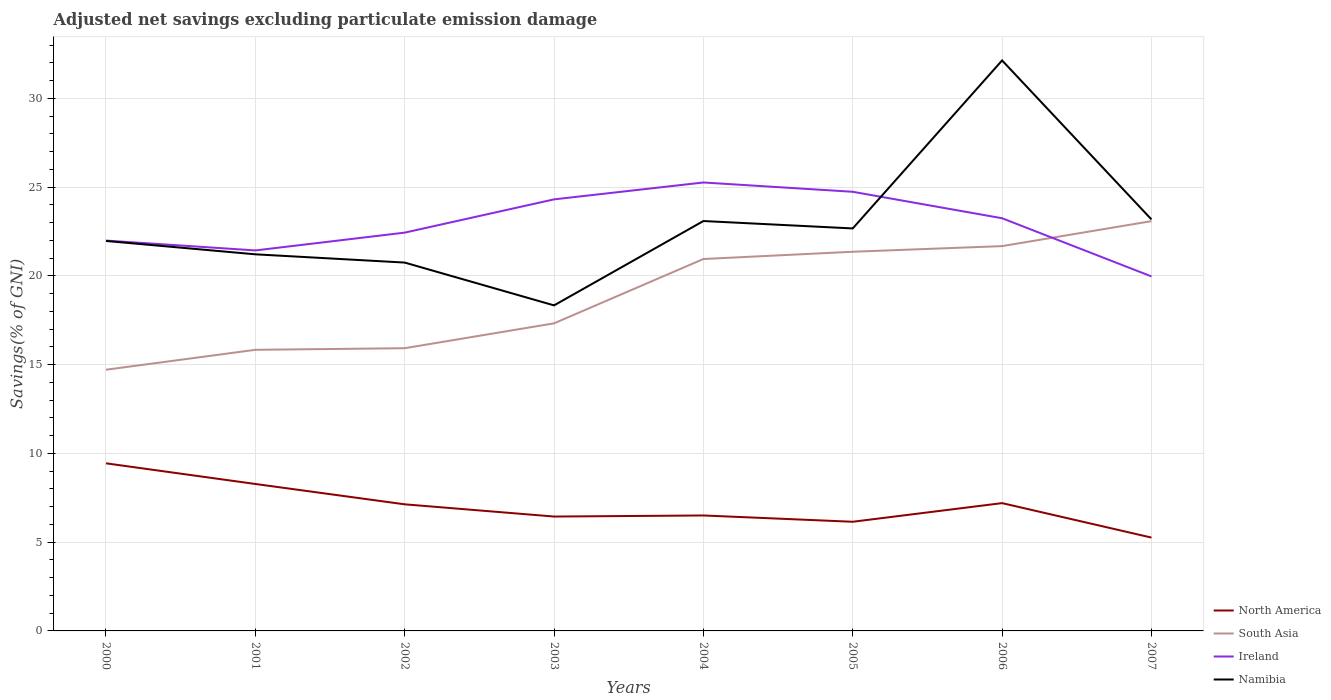Is the number of lines equal to the number of legend labels?
Keep it short and to the point. Yes. Across all years, what is the maximum adjusted net savings in South Asia?
Ensure brevity in your answer.  14.71. In which year was the adjusted net savings in North America maximum?
Ensure brevity in your answer.  2007. What is the total adjusted net savings in South Asia in the graph?
Your answer should be very brief. -5.52. What is the difference between the highest and the second highest adjusted net savings in Ireland?
Offer a terse response. 5.29. What is the difference between the highest and the lowest adjusted net savings in Namibia?
Provide a succinct answer. 3. What is the difference between two consecutive major ticks on the Y-axis?
Your answer should be very brief. 5. Are the values on the major ticks of Y-axis written in scientific E-notation?
Offer a very short reply. No. Does the graph contain any zero values?
Your response must be concise. No. Does the graph contain grids?
Make the answer very short. Yes. How many legend labels are there?
Offer a terse response. 4. What is the title of the graph?
Your answer should be very brief. Adjusted net savings excluding particulate emission damage. What is the label or title of the Y-axis?
Your answer should be very brief. Savings(% of GNI). What is the Savings(% of GNI) of North America in 2000?
Your answer should be compact. 9.44. What is the Savings(% of GNI) of South Asia in 2000?
Provide a succinct answer. 14.71. What is the Savings(% of GNI) of Ireland in 2000?
Provide a short and direct response. 21.99. What is the Savings(% of GNI) of Namibia in 2000?
Offer a very short reply. 21.97. What is the Savings(% of GNI) of North America in 2001?
Offer a terse response. 8.28. What is the Savings(% of GNI) in South Asia in 2001?
Make the answer very short. 15.84. What is the Savings(% of GNI) in Ireland in 2001?
Provide a succinct answer. 21.44. What is the Savings(% of GNI) in Namibia in 2001?
Ensure brevity in your answer.  21.22. What is the Savings(% of GNI) of North America in 2002?
Make the answer very short. 7.13. What is the Savings(% of GNI) in South Asia in 2002?
Offer a very short reply. 15.93. What is the Savings(% of GNI) in Ireland in 2002?
Provide a succinct answer. 22.44. What is the Savings(% of GNI) in Namibia in 2002?
Provide a succinct answer. 20.75. What is the Savings(% of GNI) in North America in 2003?
Provide a succinct answer. 6.44. What is the Savings(% of GNI) in South Asia in 2003?
Offer a terse response. 17.33. What is the Savings(% of GNI) of Ireland in 2003?
Your answer should be very brief. 24.31. What is the Savings(% of GNI) in Namibia in 2003?
Your answer should be very brief. 18.34. What is the Savings(% of GNI) in North America in 2004?
Provide a succinct answer. 6.5. What is the Savings(% of GNI) in South Asia in 2004?
Give a very brief answer. 20.95. What is the Savings(% of GNI) of Ireland in 2004?
Your answer should be compact. 25.26. What is the Savings(% of GNI) of Namibia in 2004?
Offer a very short reply. 23.09. What is the Savings(% of GNI) of North America in 2005?
Offer a terse response. 6.15. What is the Savings(% of GNI) in South Asia in 2005?
Offer a terse response. 21.36. What is the Savings(% of GNI) of Ireland in 2005?
Make the answer very short. 24.74. What is the Savings(% of GNI) in Namibia in 2005?
Keep it short and to the point. 22.68. What is the Savings(% of GNI) in North America in 2006?
Ensure brevity in your answer.  7.2. What is the Savings(% of GNI) in South Asia in 2006?
Make the answer very short. 21.68. What is the Savings(% of GNI) in Ireland in 2006?
Ensure brevity in your answer.  23.25. What is the Savings(% of GNI) of Namibia in 2006?
Your answer should be very brief. 32.14. What is the Savings(% of GNI) of North America in 2007?
Make the answer very short. 5.26. What is the Savings(% of GNI) in South Asia in 2007?
Offer a terse response. 23.09. What is the Savings(% of GNI) in Ireland in 2007?
Offer a terse response. 19.97. What is the Savings(% of GNI) in Namibia in 2007?
Provide a succinct answer. 23.18. Across all years, what is the maximum Savings(% of GNI) in North America?
Your answer should be compact. 9.44. Across all years, what is the maximum Savings(% of GNI) in South Asia?
Keep it short and to the point. 23.09. Across all years, what is the maximum Savings(% of GNI) of Ireland?
Your answer should be compact. 25.26. Across all years, what is the maximum Savings(% of GNI) of Namibia?
Offer a very short reply. 32.14. Across all years, what is the minimum Savings(% of GNI) in North America?
Provide a succinct answer. 5.26. Across all years, what is the minimum Savings(% of GNI) in South Asia?
Ensure brevity in your answer.  14.71. Across all years, what is the minimum Savings(% of GNI) in Ireland?
Keep it short and to the point. 19.97. Across all years, what is the minimum Savings(% of GNI) in Namibia?
Offer a very short reply. 18.34. What is the total Savings(% of GNI) of North America in the graph?
Ensure brevity in your answer.  56.41. What is the total Savings(% of GNI) in South Asia in the graph?
Your answer should be compact. 150.89. What is the total Savings(% of GNI) of Ireland in the graph?
Offer a terse response. 183.4. What is the total Savings(% of GNI) in Namibia in the graph?
Provide a succinct answer. 183.37. What is the difference between the Savings(% of GNI) in North America in 2000 and that in 2001?
Keep it short and to the point. 1.16. What is the difference between the Savings(% of GNI) of South Asia in 2000 and that in 2001?
Give a very brief answer. -1.12. What is the difference between the Savings(% of GNI) in Ireland in 2000 and that in 2001?
Your answer should be very brief. 0.56. What is the difference between the Savings(% of GNI) of Namibia in 2000 and that in 2001?
Provide a short and direct response. 0.75. What is the difference between the Savings(% of GNI) of North America in 2000 and that in 2002?
Offer a very short reply. 2.31. What is the difference between the Savings(% of GNI) of South Asia in 2000 and that in 2002?
Offer a terse response. -1.21. What is the difference between the Savings(% of GNI) of Ireland in 2000 and that in 2002?
Offer a terse response. -0.45. What is the difference between the Savings(% of GNI) in Namibia in 2000 and that in 2002?
Your answer should be compact. 1.22. What is the difference between the Savings(% of GNI) in North America in 2000 and that in 2003?
Give a very brief answer. 3. What is the difference between the Savings(% of GNI) of South Asia in 2000 and that in 2003?
Your response must be concise. -2.61. What is the difference between the Savings(% of GNI) in Ireland in 2000 and that in 2003?
Your answer should be compact. -2.32. What is the difference between the Savings(% of GNI) of Namibia in 2000 and that in 2003?
Your response must be concise. 3.63. What is the difference between the Savings(% of GNI) in North America in 2000 and that in 2004?
Your answer should be compact. 2.94. What is the difference between the Savings(% of GNI) in South Asia in 2000 and that in 2004?
Keep it short and to the point. -6.24. What is the difference between the Savings(% of GNI) of Ireland in 2000 and that in 2004?
Your answer should be very brief. -3.27. What is the difference between the Savings(% of GNI) in Namibia in 2000 and that in 2004?
Provide a succinct answer. -1.12. What is the difference between the Savings(% of GNI) in North America in 2000 and that in 2005?
Your answer should be very brief. 3.29. What is the difference between the Savings(% of GNI) of South Asia in 2000 and that in 2005?
Your response must be concise. -6.65. What is the difference between the Savings(% of GNI) of Ireland in 2000 and that in 2005?
Your response must be concise. -2.75. What is the difference between the Savings(% of GNI) in Namibia in 2000 and that in 2005?
Make the answer very short. -0.71. What is the difference between the Savings(% of GNI) in North America in 2000 and that in 2006?
Provide a succinct answer. 2.24. What is the difference between the Savings(% of GNI) of South Asia in 2000 and that in 2006?
Your response must be concise. -6.96. What is the difference between the Savings(% of GNI) of Ireland in 2000 and that in 2006?
Keep it short and to the point. -1.26. What is the difference between the Savings(% of GNI) of Namibia in 2000 and that in 2006?
Offer a terse response. -10.17. What is the difference between the Savings(% of GNI) in North America in 2000 and that in 2007?
Your response must be concise. 4.18. What is the difference between the Savings(% of GNI) in South Asia in 2000 and that in 2007?
Offer a very short reply. -8.37. What is the difference between the Savings(% of GNI) in Ireland in 2000 and that in 2007?
Give a very brief answer. 2.02. What is the difference between the Savings(% of GNI) of Namibia in 2000 and that in 2007?
Your response must be concise. -1.21. What is the difference between the Savings(% of GNI) in North America in 2001 and that in 2002?
Your response must be concise. 1.15. What is the difference between the Savings(% of GNI) of South Asia in 2001 and that in 2002?
Provide a succinct answer. -0.09. What is the difference between the Savings(% of GNI) in Ireland in 2001 and that in 2002?
Your response must be concise. -1. What is the difference between the Savings(% of GNI) of Namibia in 2001 and that in 2002?
Give a very brief answer. 0.47. What is the difference between the Savings(% of GNI) in North America in 2001 and that in 2003?
Your answer should be very brief. 1.83. What is the difference between the Savings(% of GNI) of South Asia in 2001 and that in 2003?
Provide a short and direct response. -1.49. What is the difference between the Savings(% of GNI) of Ireland in 2001 and that in 2003?
Offer a terse response. -2.88. What is the difference between the Savings(% of GNI) in Namibia in 2001 and that in 2003?
Your answer should be very brief. 2.88. What is the difference between the Savings(% of GNI) of North America in 2001 and that in 2004?
Your response must be concise. 1.77. What is the difference between the Savings(% of GNI) in South Asia in 2001 and that in 2004?
Offer a terse response. -5.12. What is the difference between the Savings(% of GNI) of Ireland in 2001 and that in 2004?
Your answer should be compact. -3.83. What is the difference between the Savings(% of GNI) in Namibia in 2001 and that in 2004?
Your answer should be compact. -1.87. What is the difference between the Savings(% of GNI) in North America in 2001 and that in 2005?
Make the answer very short. 2.13. What is the difference between the Savings(% of GNI) of South Asia in 2001 and that in 2005?
Offer a very short reply. -5.53. What is the difference between the Savings(% of GNI) in Ireland in 2001 and that in 2005?
Your response must be concise. -3.3. What is the difference between the Savings(% of GNI) of Namibia in 2001 and that in 2005?
Keep it short and to the point. -1.46. What is the difference between the Savings(% of GNI) in North America in 2001 and that in 2006?
Offer a very short reply. 1.08. What is the difference between the Savings(% of GNI) of South Asia in 2001 and that in 2006?
Your answer should be compact. -5.84. What is the difference between the Savings(% of GNI) in Ireland in 2001 and that in 2006?
Ensure brevity in your answer.  -1.81. What is the difference between the Savings(% of GNI) in Namibia in 2001 and that in 2006?
Provide a short and direct response. -10.92. What is the difference between the Savings(% of GNI) in North America in 2001 and that in 2007?
Your answer should be very brief. 3.02. What is the difference between the Savings(% of GNI) in South Asia in 2001 and that in 2007?
Provide a short and direct response. -7.25. What is the difference between the Savings(% of GNI) in Ireland in 2001 and that in 2007?
Make the answer very short. 1.46. What is the difference between the Savings(% of GNI) of Namibia in 2001 and that in 2007?
Ensure brevity in your answer.  -1.97. What is the difference between the Savings(% of GNI) of North America in 2002 and that in 2003?
Offer a very short reply. 0.69. What is the difference between the Savings(% of GNI) in South Asia in 2002 and that in 2003?
Offer a very short reply. -1.4. What is the difference between the Savings(% of GNI) of Ireland in 2002 and that in 2003?
Keep it short and to the point. -1.87. What is the difference between the Savings(% of GNI) of Namibia in 2002 and that in 2003?
Your response must be concise. 2.41. What is the difference between the Savings(% of GNI) in North America in 2002 and that in 2004?
Give a very brief answer. 0.63. What is the difference between the Savings(% of GNI) of South Asia in 2002 and that in 2004?
Your answer should be very brief. -5.02. What is the difference between the Savings(% of GNI) in Ireland in 2002 and that in 2004?
Offer a terse response. -2.83. What is the difference between the Savings(% of GNI) of Namibia in 2002 and that in 2004?
Make the answer very short. -2.34. What is the difference between the Savings(% of GNI) of North America in 2002 and that in 2005?
Offer a terse response. 0.98. What is the difference between the Savings(% of GNI) of South Asia in 2002 and that in 2005?
Keep it short and to the point. -5.43. What is the difference between the Savings(% of GNI) of Ireland in 2002 and that in 2005?
Make the answer very short. -2.3. What is the difference between the Savings(% of GNI) of Namibia in 2002 and that in 2005?
Keep it short and to the point. -1.92. What is the difference between the Savings(% of GNI) of North America in 2002 and that in 2006?
Give a very brief answer. -0.07. What is the difference between the Savings(% of GNI) of South Asia in 2002 and that in 2006?
Provide a short and direct response. -5.75. What is the difference between the Savings(% of GNI) of Ireland in 2002 and that in 2006?
Ensure brevity in your answer.  -0.81. What is the difference between the Savings(% of GNI) in Namibia in 2002 and that in 2006?
Offer a terse response. -11.39. What is the difference between the Savings(% of GNI) of North America in 2002 and that in 2007?
Give a very brief answer. 1.87. What is the difference between the Savings(% of GNI) in South Asia in 2002 and that in 2007?
Your response must be concise. -7.16. What is the difference between the Savings(% of GNI) in Ireland in 2002 and that in 2007?
Offer a very short reply. 2.47. What is the difference between the Savings(% of GNI) in Namibia in 2002 and that in 2007?
Your response must be concise. -2.43. What is the difference between the Savings(% of GNI) of North America in 2003 and that in 2004?
Your response must be concise. -0.06. What is the difference between the Savings(% of GNI) of South Asia in 2003 and that in 2004?
Your answer should be very brief. -3.62. What is the difference between the Savings(% of GNI) in Ireland in 2003 and that in 2004?
Offer a terse response. -0.95. What is the difference between the Savings(% of GNI) of Namibia in 2003 and that in 2004?
Keep it short and to the point. -4.75. What is the difference between the Savings(% of GNI) of North America in 2003 and that in 2005?
Your response must be concise. 0.29. What is the difference between the Savings(% of GNI) in South Asia in 2003 and that in 2005?
Provide a succinct answer. -4.03. What is the difference between the Savings(% of GNI) of Ireland in 2003 and that in 2005?
Offer a very short reply. -0.43. What is the difference between the Savings(% of GNI) in Namibia in 2003 and that in 2005?
Your answer should be compact. -4.34. What is the difference between the Savings(% of GNI) in North America in 2003 and that in 2006?
Provide a short and direct response. -0.76. What is the difference between the Savings(% of GNI) in South Asia in 2003 and that in 2006?
Provide a succinct answer. -4.35. What is the difference between the Savings(% of GNI) in Ireland in 2003 and that in 2006?
Your response must be concise. 1.06. What is the difference between the Savings(% of GNI) of Namibia in 2003 and that in 2006?
Your answer should be compact. -13.8. What is the difference between the Savings(% of GNI) in North America in 2003 and that in 2007?
Your answer should be very brief. 1.19. What is the difference between the Savings(% of GNI) of South Asia in 2003 and that in 2007?
Make the answer very short. -5.76. What is the difference between the Savings(% of GNI) in Ireland in 2003 and that in 2007?
Keep it short and to the point. 4.34. What is the difference between the Savings(% of GNI) of Namibia in 2003 and that in 2007?
Ensure brevity in your answer.  -4.84. What is the difference between the Savings(% of GNI) of North America in 2004 and that in 2005?
Your answer should be very brief. 0.35. What is the difference between the Savings(% of GNI) of South Asia in 2004 and that in 2005?
Offer a terse response. -0.41. What is the difference between the Savings(% of GNI) in Ireland in 2004 and that in 2005?
Keep it short and to the point. 0.52. What is the difference between the Savings(% of GNI) of Namibia in 2004 and that in 2005?
Make the answer very short. 0.42. What is the difference between the Savings(% of GNI) of North America in 2004 and that in 2006?
Provide a succinct answer. -0.7. What is the difference between the Savings(% of GNI) in South Asia in 2004 and that in 2006?
Offer a terse response. -0.73. What is the difference between the Savings(% of GNI) of Ireland in 2004 and that in 2006?
Give a very brief answer. 2.01. What is the difference between the Savings(% of GNI) of Namibia in 2004 and that in 2006?
Ensure brevity in your answer.  -9.05. What is the difference between the Savings(% of GNI) of North America in 2004 and that in 2007?
Ensure brevity in your answer.  1.25. What is the difference between the Savings(% of GNI) in South Asia in 2004 and that in 2007?
Provide a short and direct response. -2.13. What is the difference between the Savings(% of GNI) in Ireland in 2004 and that in 2007?
Offer a very short reply. 5.29. What is the difference between the Savings(% of GNI) in Namibia in 2004 and that in 2007?
Your answer should be compact. -0.09. What is the difference between the Savings(% of GNI) of North America in 2005 and that in 2006?
Offer a very short reply. -1.05. What is the difference between the Savings(% of GNI) in South Asia in 2005 and that in 2006?
Keep it short and to the point. -0.32. What is the difference between the Savings(% of GNI) of Ireland in 2005 and that in 2006?
Provide a succinct answer. 1.49. What is the difference between the Savings(% of GNI) of Namibia in 2005 and that in 2006?
Keep it short and to the point. -9.46. What is the difference between the Savings(% of GNI) in North America in 2005 and that in 2007?
Offer a very short reply. 0.89. What is the difference between the Savings(% of GNI) of South Asia in 2005 and that in 2007?
Offer a terse response. -1.72. What is the difference between the Savings(% of GNI) in Ireland in 2005 and that in 2007?
Your response must be concise. 4.77. What is the difference between the Savings(% of GNI) of Namibia in 2005 and that in 2007?
Your answer should be very brief. -0.51. What is the difference between the Savings(% of GNI) in North America in 2006 and that in 2007?
Your response must be concise. 1.94. What is the difference between the Savings(% of GNI) of South Asia in 2006 and that in 2007?
Offer a very short reply. -1.41. What is the difference between the Savings(% of GNI) in Ireland in 2006 and that in 2007?
Provide a succinct answer. 3.28. What is the difference between the Savings(% of GNI) of Namibia in 2006 and that in 2007?
Provide a short and direct response. 8.96. What is the difference between the Savings(% of GNI) of North America in 2000 and the Savings(% of GNI) of South Asia in 2001?
Give a very brief answer. -6.39. What is the difference between the Savings(% of GNI) in North America in 2000 and the Savings(% of GNI) in Ireland in 2001?
Keep it short and to the point. -11.99. What is the difference between the Savings(% of GNI) in North America in 2000 and the Savings(% of GNI) in Namibia in 2001?
Offer a terse response. -11.77. What is the difference between the Savings(% of GNI) in South Asia in 2000 and the Savings(% of GNI) in Ireland in 2001?
Ensure brevity in your answer.  -6.72. What is the difference between the Savings(% of GNI) of South Asia in 2000 and the Savings(% of GNI) of Namibia in 2001?
Ensure brevity in your answer.  -6.5. What is the difference between the Savings(% of GNI) in Ireland in 2000 and the Savings(% of GNI) in Namibia in 2001?
Give a very brief answer. 0.77. What is the difference between the Savings(% of GNI) in North America in 2000 and the Savings(% of GNI) in South Asia in 2002?
Offer a very short reply. -6.49. What is the difference between the Savings(% of GNI) in North America in 2000 and the Savings(% of GNI) in Ireland in 2002?
Your answer should be compact. -13. What is the difference between the Savings(% of GNI) in North America in 2000 and the Savings(% of GNI) in Namibia in 2002?
Your answer should be compact. -11.31. What is the difference between the Savings(% of GNI) of South Asia in 2000 and the Savings(% of GNI) of Ireland in 2002?
Keep it short and to the point. -7.72. What is the difference between the Savings(% of GNI) in South Asia in 2000 and the Savings(% of GNI) in Namibia in 2002?
Your answer should be very brief. -6.04. What is the difference between the Savings(% of GNI) of Ireland in 2000 and the Savings(% of GNI) of Namibia in 2002?
Provide a succinct answer. 1.24. What is the difference between the Savings(% of GNI) in North America in 2000 and the Savings(% of GNI) in South Asia in 2003?
Offer a terse response. -7.89. What is the difference between the Savings(% of GNI) of North America in 2000 and the Savings(% of GNI) of Ireland in 2003?
Provide a succinct answer. -14.87. What is the difference between the Savings(% of GNI) in North America in 2000 and the Savings(% of GNI) in Namibia in 2003?
Provide a succinct answer. -8.9. What is the difference between the Savings(% of GNI) in South Asia in 2000 and the Savings(% of GNI) in Ireland in 2003?
Your answer should be compact. -9.6. What is the difference between the Savings(% of GNI) of South Asia in 2000 and the Savings(% of GNI) of Namibia in 2003?
Provide a succinct answer. -3.62. What is the difference between the Savings(% of GNI) of Ireland in 2000 and the Savings(% of GNI) of Namibia in 2003?
Offer a terse response. 3.65. What is the difference between the Savings(% of GNI) of North America in 2000 and the Savings(% of GNI) of South Asia in 2004?
Your response must be concise. -11.51. What is the difference between the Savings(% of GNI) of North America in 2000 and the Savings(% of GNI) of Ireland in 2004?
Offer a very short reply. -15.82. What is the difference between the Savings(% of GNI) in North America in 2000 and the Savings(% of GNI) in Namibia in 2004?
Ensure brevity in your answer.  -13.65. What is the difference between the Savings(% of GNI) in South Asia in 2000 and the Savings(% of GNI) in Ireland in 2004?
Offer a terse response. -10.55. What is the difference between the Savings(% of GNI) of South Asia in 2000 and the Savings(% of GNI) of Namibia in 2004?
Provide a short and direct response. -8.38. What is the difference between the Savings(% of GNI) in Ireland in 2000 and the Savings(% of GNI) in Namibia in 2004?
Give a very brief answer. -1.1. What is the difference between the Savings(% of GNI) in North America in 2000 and the Savings(% of GNI) in South Asia in 2005?
Offer a terse response. -11.92. What is the difference between the Savings(% of GNI) of North America in 2000 and the Savings(% of GNI) of Ireland in 2005?
Your answer should be compact. -15.3. What is the difference between the Savings(% of GNI) in North America in 2000 and the Savings(% of GNI) in Namibia in 2005?
Keep it short and to the point. -13.23. What is the difference between the Savings(% of GNI) in South Asia in 2000 and the Savings(% of GNI) in Ireland in 2005?
Keep it short and to the point. -10.02. What is the difference between the Savings(% of GNI) in South Asia in 2000 and the Savings(% of GNI) in Namibia in 2005?
Provide a short and direct response. -7.96. What is the difference between the Savings(% of GNI) in Ireland in 2000 and the Savings(% of GNI) in Namibia in 2005?
Offer a terse response. -0.68. What is the difference between the Savings(% of GNI) of North America in 2000 and the Savings(% of GNI) of South Asia in 2006?
Ensure brevity in your answer.  -12.24. What is the difference between the Savings(% of GNI) in North America in 2000 and the Savings(% of GNI) in Ireland in 2006?
Your answer should be compact. -13.81. What is the difference between the Savings(% of GNI) in North America in 2000 and the Savings(% of GNI) in Namibia in 2006?
Offer a very short reply. -22.7. What is the difference between the Savings(% of GNI) of South Asia in 2000 and the Savings(% of GNI) of Ireland in 2006?
Offer a terse response. -8.53. What is the difference between the Savings(% of GNI) in South Asia in 2000 and the Savings(% of GNI) in Namibia in 2006?
Your answer should be compact. -17.43. What is the difference between the Savings(% of GNI) in Ireland in 2000 and the Savings(% of GNI) in Namibia in 2006?
Make the answer very short. -10.15. What is the difference between the Savings(% of GNI) of North America in 2000 and the Savings(% of GNI) of South Asia in 2007?
Your answer should be compact. -13.64. What is the difference between the Savings(% of GNI) of North America in 2000 and the Savings(% of GNI) of Ireland in 2007?
Your response must be concise. -10.53. What is the difference between the Savings(% of GNI) of North America in 2000 and the Savings(% of GNI) of Namibia in 2007?
Your response must be concise. -13.74. What is the difference between the Savings(% of GNI) of South Asia in 2000 and the Savings(% of GNI) of Ireland in 2007?
Your answer should be compact. -5.26. What is the difference between the Savings(% of GNI) of South Asia in 2000 and the Savings(% of GNI) of Namibia in 2007?
Your response must be concise. -8.47. What is the difference between the Savings(% of GNI) of Ireland in 2000 and the Savings(% of GNI) of Namibia in 2007?
Give a very brief answer. -1.19. What is the difference between the Savings(% of GNI) of North America in 2001 and the Savings(% of GNI) of South Asia in 2002?
Your response must be concise. -7.65. What is the difference between the Savings(% of GNI) in North America in 2001 and the Savings(% of GNI) in Ireland in 2002?
Provide a short and direct response. -14.16. What is the difference between the Savings(% of GNI) in North America in 2001 and the Savings(% of GNI) in Namibia in 2002?
Your answer should be compact. -12.47. What is the difference between the Savings(% of GNI) in South Asia in 2001 and the Savings(% of GNI) in Ireland in 2002?
Your response must be concise. -6.6. What is the difference between the Savings(% of GNI) of South Asia in 2001 and the Savings(% of GNI) of Namibia in 2002?
Offer a terse response. -4.92. What is the difference between the Savings(% of GNI) in Ireland in 2001 and the Savings(% of GNI) in Namibia in 2002?
Provide a short and direct response. 0.68. What is the difference between the Savings(% of GNI) of North America in 2001 and the Savings(% of GNI) of South Asia in 2003?
Keep it short and to the point. -9.05. What is the difference between the Savings(% of GNI) of North America in 2001 and the Savings(% of GNI) of Ireland in 2003?
Your answer should be compact. -16.03. What is the difference between the Savings(% of GNI) of North America in 2001 and the Savings(% of GNI) of Namibia in 2003?
Provide a succinct answer. -10.06. What is the difference between the Savings(% of GNI) of South Asia in 2001 and the Savings(% of GNI) of Ireland in 2003?
Ensure brevity in your answer.  -8.48. What is the difference between the Savings(% of GNI) in South Asia in 2001 and the Savings(% of GNI) in Namibia in 2003?
Offer a very short reply. -2.5. What is the difference between the Savings(% of GNI) in Ireland in 2001 and the Savings(% of GNI) in Namibia in 2003?
Ensure brevity in your answer.  3.1. What is the difference between the Savings(% of GNI) of North America in 2001 and the Savings(% of GNI) of South Asia in 2004?
Make the answer very short. -12.67. What is the difference between the Savings(% of GNI) in North America in 2001 and the Savings(% of GNI) in Ireland in 2004?
Make the answer very short. -16.98. What is the difference between the Savings(% of GNI) of North America in 2001 and the Savings(% of GNI) of Namibia in 2004?
Provide a short and direct response. -14.81. What is the difference between the Savings(% of GNI) in South Asia in 2001 and the Savings(% of GNI) in Ireland in 2004?
Ensure brevity in your answer.  -9.43. What is the difference between the Savings(% of GNI) of South Asia in 2001 and the Savings(% of GNI) of Namibia in 2004?
Offer a very short reply. -7.26. What is the difference between the Savings(% of GNI) of Ireland in 2001 and the Savings(% of GNI) of Namibia in 2004?
Your answer should be compact. -1.66. What is the difference between the Savings(% of GNI) of North America in 2001 and the Savings(% of GNI) of South Asia in 2005?
Your answer should be very brief. -13.08. What is the difference between the Savings(% of GNI) in North America in 2001 and the Savings(% of GNI) in Ireland in 2005?
Provide a succinct answer. -16.46. What is the difference between the Savings(% of GNI) in North America in 2001 and the Savings(% of GNI) in Namibia in 2005?
Offer a terse response. -14.4. What is the difference between the Savings(% of GNI) of South Asia in 2001 and the Savings(% of GNI) of Ireland in 2005?
Make the answer very short. -8.9. What is the difference between the Savings(% of GNI) in South Asia in 2001 and the Savings(% of GNI) in Namibia in 2005?
Your answer should be very brief. -6.84. What is the difference between the Savings(% of GNI) of Ireland in 2001 and the Savings(% of GNI) of Namibia in 2005?
Make the answer very short. -1.24. What is the difference between the Savings(% of GNI) of North America in 2001 and the Savings(% of GNI) of South Asia in 2006?
Your answer should be very brief. -13.4. What is the difference between the Savings(% of GNI) in North America in 2001 and the Savings(% of GNI) in Ireland in 2006?
Your response must be concise. -14.97. What is the difference between the Savings(% of GNI) in North America in 2001 and the Savings(% of GNI) in Namibia in 2006?
Your response must be concise. -23.86. What is the difference between the Savings(% of GNI) of South Asia in 2001 and the Savings(% of GNI) of Ireland in 2006?
Give a very brief answer. -7.41. What is the difference between the Savings(% of GNI) of South Asia in 2001 and the Savings(% of GNI) of Namibia in 2006?
Offer a terse response. -16.3. What is the difference between the Savings(% of GNI) of Ireland in 2001 and the Savings(% of GNI) of Namibia in 2006?
Ensure brevity in your answer.  -10.7. What is the difference between the Savings(% of GNI) of North America in 2001 and the Savings(% of GNI) of South Asia in 2007?
Keep it short and to the point. -14.81. What is the difference between the Savings(% of GNI) in North America in 2001 and the Savings(% of GNI) in Ireland in 2007?
Your answer should be compact. -11.69. What is the difference between the Savings(% of GNI) in North America in 2001 and the Savings(% of GNI) in Namibia in 2007?
Keep it short and to the point. -14.9. What is the difference between the Savings(% of GNI) of South Asia in 2001 and the Savings(% of GNI) of Ireland in 2007?
Your answer should be compact. -4.14. What is the difference between the Savings(% of GNI) in South Asia in 2001 and the Savings(% of GNI) in Namibia in 2007?
Your response must be concise. -7.35. What is the difference between the Savings(% of GNI) of Ireland in 2001 and the Savings(% of GNI) of Namibia in 2007?
Make the answer very short. -1.75. What is the difference between the Savings(% of GNI) in North America in 2002 and the Savings(% of GNI) in South Asia in 2003?
Your response must be concise. -10.2. What is the difference between the Savings(% of GNI) of North America in 2002 and the Savings(% of GNI) of Ireland in 2003?
Make the answer very short. -17.18. What is the difference between the Savings(% of GNI) of North America in 2002 and the Savings(% of GNI) of Namibia in 2003?
Offer a terse response. -11.21. What is the difference between the Savings(% of GNI) of South Asia in 2002 and the Savings(% of GNI) of Ireland in 2003?
Give a very brief answer. -8.38. What is the difference between the Savings(% of GNI) in South Asia in 2002 and the Savings(% of GNI) in Namibia in 2003?
Provide a short and direct response. -2.41. What is the difference between the Savings(% of GNI) of Ireland in 2002 and the Savings(% of GNI) of Namibia in 2003?
Provide a short and direct response. 4.1. What is the difference between the Savings(% of GNI) of North America in 2002 and the Savings(% of GNI) of South Asia in 2004?
Offer a very short reply. -13.82. What is the difference between the Savings(% of GNI) of North America in 2002 and the Savings(% of GNI) of Ireland in 2004?
Provide a short and direct response. -18.13. What is the difference between the Savings(% of GNI) in North America in 2002 and the Savings(% of GNI) in Namibia in 2004?
Your answer should be compact. -15.96. What is the difference between the Savings(% of GNI) of South Asia in 2002 and the Savings(% of GNI) of Ireland in 2004?
Keep it short and to the point. -9.34. What is the difference between the Savings(% of GNI) of South Asia in 2002 and the Savings(% of GNI) of Namibia in 2004?
Give a very brief answer. -7.16. What is the difference between the Savings(% of GNI) in Ireland in 2002 and the Savings(% of GNI) in Namibia in 2004?
Your answer should be compact. -0.65. What is the difference between the Savings(% of GNI) of North America in 2002 and the Savings(% of GNI) of South Asia in 2005?
Give a very brief answer. -14.23. What is the difference between the Savings(% of GNI) of North America in 2002 and the Savings(% of GNI) of Ireland in 2005?
Provide a short and direct response. -17.61. What is the difference between the Savings(% of GNI) in North America in 2002 and the Savings(% of GNI) in Namibia in 2005?
Provide a succinct answer. -15.54. What is the difference between the Savings(% of GNI) of South Asia in 2002 and the Savings(% of GNI) of Ireland in 2005?
Your answer should be very brief. -8.81. What is the difference between the Savings(% of GNI) in South Asia in 2002 and the Savings(% of GNI) in Namibia in 2005?
Your answer should be compact. -6.75. What is the difference between the Savings(% of GNI) in Ireland in 2002 and the Savings(% of GNI) in Namibia in 2005?
Provide a short and direct response. -0.24. What is the difference between the Savings(% of GNI) in North America in 2002 and the Savings(% of GNI) in South Asia in 2006?
Provide a succinct answer. -14.55. What is the difference between the Savings(% of GNI) in North America in 2002 and the Savings(% of GNI) in Ireland in 2006?
Offer a very short reply. -16.12. What is the difference between the Savings(% of GNI) in North America in 2002 and the Savings(% of GNI) in Namibia in 2006?
Provide a succinct answer. -25.01. What is the difference between the Savings(% of GNI) in South Asia in 2002 and the Savings(% of GNI) in Ireland in 2006?
Offer a terse response. -7.32. What is the difference between the Savings(% of GNI) of South Asia in 2002 and the Savings(% of GNI) of Namibia in 2006?
Make the answer very short. -16.21. What is the difference between the Savings(% of GNI) of Ireland in 2002 and the Savings(% of GNI) of Namibia in 2006?
Provide a short and direct response. -9.7. What is the difference between the Savings(% of GNI) in North America in 2002 and the Savings(% of GNI) in South Asia in 2007?
Give a very brief answer. -15.95. What is the difference between the Savings(% of GNI) in North America in 2002 and the Savings(% of GNI) in Ireland in 2007?
Offer a very short reply. -12.84. What is the difference between the Savings(% of GNI) in North America in 2002 and the Savings(% of GNI) in Namibia in 2007?
Ensure brevity in your answer.  -16.05. What is the difference between the Savings(% of GNI) in South Asia in 2002 and the Savings(% of GNI) in Ireland in 2007?
Your answer should be compact. -4.04. What is the difference between the Savings(% of GNI) of South Asia in 2002 and the Savings(% of GNI) of Namibia in 2007?
Keep it short and to the point. -7.26. What is the difference between the Savings(% of GNI) in Ireland in 2002 and the Savings(% of GNI) in Namibia in 2007?
Provide a short and direct response. -0.75. What is the difference between the Savings(% of GNI) of North America in 2003 and the Savings(% of GNI) of South Asia in 2004?
Give a very brief answer. -14.51. What is the difference between the Savings(% of GNI) of North America in 2003 and the Savings(% of GNI) of Ireland in 2004?
Offer a terse response. -18.82. What is the difference between the Savings(% of GNI) of North America in 2003 and the Savings(% of GNI) of Namibia in 2004?
Offer a very short reply. -16.65. What is the difference between the Savings(% of GNI) in South Asia in 2003 and the Savings(% of GNI) in Ireland in 2004?
Your answer should be very brief. -7.94. What is the difference between the Savings(% of GNI) in South Asia in 2003 and the Savings(% of GNI) in Namibia in 2004?
Your response must be concise. -5.76. What is the difference between the Savings(% of GNI) in Ireland in 2003 and the Savings(% of GNI) in Namibia in 2004?
Keep it short and to the point. 1.22. What is the difference between the Savings(% of GNI) of North America in 2003 and the Savings(% of GNI) of South Asia in 2005?
Ensure brevity in your answer.  -14.92. What is the difference between the Savings(% of GNI) in North America in 2003 and the Savings(% of GNI) in Ireland in 2005?
Offer a very short reply. -18.3. What is the difference between the Savings(% of GNI) of North America in 2003 and the Savings(% of GNI) of Namibia in 2005?
Your answer should be compact. -16.23. What is the difference between the Savings(% of GNI) of South Asia in 2003 and the Savings(% of GNI) of Ireland in 2005?
Offer a terse response. -7.41. What is the difference between the Savings(% of GNI) of South Asia in 2003 and the Savings(% of GNI) of Namibia in 2005?
Make the answer very short. -5.35. What is the difference between the Savings(% of GNI) in Ireland in 2003 and the Savings(% of GNI) in Namibia in 2005?
Make the answer very short. 1.64. What is the difference between the Savings(% of GNI) in North America in 2003 and the Savings(% of GNI) in South Asia in 2006?
Give a very brief answer. -15.24. What is the difference between the Savings(% of GNI) in North America in 2003 and the Savings(% of GNI) in Ireland in 2006?
Your answer should be very brief. -16.81. What is the difference between the Savings(% of GNI) in North America in 2003 and the Savings(% of GNI) in Namibia in 2006?
Provide a succinct answer. -25.7. What is the difference between the Savings(% of GNI) in South Asia in 2003 and the Savings(% of GNI) in Ireland in 2006?
Make the answer very short. -5.92. What is the difference between the Savings(% of GNI) in South Asia in 2003 and the Savings(% of GNI) in Namibia in 2006?
Keep it short and to the point. -14.81. What is the difference between the Savings(% of GNI) in Ireland in 2003 and the Savings(% of GNI) in Namibia in 2006?
Make the answer very short. -7.83. What is the difference between the Savings(% of GNI) of North America in 2003 and the Savings(% of GNI) of South Asia in 2007?
Provide a succinct answer. -16.64. What is the difference between the Savings(% of GNI) in North America in 2003 and the Savings(% of GNI) in Ireland in 2007?
Give a very brief answer. -13.53. What is the difference between the Savings(% of GNI) of North America in 2003 and the Savings(% of GNI) of Namibia in 2007?
Keep it short and to the point. -16.74. What is the difference between the Savings(% of GNI) of South Asia in 2003 and the Savings(% of GNI) of Ireland in 2007?
Your response must be concise. -2.64. What is the difference between the Savings(% of GNI) in South Asia in 2003 and the Savings(% of GNI) in Namibia in 2007?
Ensure brevity in your answer.  -5.86. What is the difference between the Savings(% of GNI) of Ireland in 2003 and the Savings(% of GNI) of Namibia in 2007?
Ensure brevity in your answer.  1.13. What is the difference between the Savings(% of GNI) in North America in 2004 and the Savings(% of GNI) in South Asia in 2005?
Offer a very short reply. -14.86. What is the difference between the Savings(% of GNI) of North America in 2004 and the Savings(% of GNI) of Ireland in 2005?
Ensure brevity in your answer.  -18.24. What is the difference between the Savings(% of GNI) of North America in 2004 and the Savings(% of GNI) of Namibia in 2005?
Make the answer very short. -16.17. What is the difference between the Savings(% of GNI) of South Asia in 2004 and the Savings(% of GNI) of Ireland in 2005?
Provide a succinct answer. -3.79. What is the difference between the Savings(% of GNI) in South Asia in 2004 and the Savings(% of GNI) in Namibia in 2005?
Keep it short and to the point. -1.72. What is the difference between the Savings(% of GNI) of Ireland in 2004 and the Savings(% of GNI) of Namibia in 2005?
Keep it short and to the point. 2.59. What is the difference between the Savings(% of GNI) in North America in 2004 and the Savings(% of GNI) in South Asia in 2006?
Give a very brief answer. -15.18. What is the difference between the Savings(% of GNI) in North America in 2004 and the Savings(% of GNI) in Ireland in 2006?
Keep it short and to the point. -16.75. What is the difference between the Savings(% of GNI) in North America in 2004 and the Savings(% of GNI) in Namibia in 2006?
Offer a terse response. -25.64. What is the difference between the Savings(% of GNI) of South Asia in 2004 and the Savings(% of GNI) of Ireland in 2006?
Make the answer very short. -2.3. What is the difference between the Savings(% of GNI) of South Asia in 2004 and the Savings(% of GNI) of Namibia in 2006?
Offer a terse response. -11.19. What is the difference between the Savings(% of GNI) in Ireland in 2004 and the Savings(% of GNI) in Namibia in 2006?
Provide a succinct answer. -6.88. What is the difference between the Savings(% of GNI) of North America in 2004 and the Savings(% of GNI) of South Asia in 2007?
Your answer should be compact. -16.58. What is the difference between the Savings(% of GNI) in North America in 2004 and the Savings(% of GNI) in Ireland in 2007?
Keep it short and to the point. -13.47. What is the difference between the Savings(% of GNI) in North America in 2004 and the Savings(% of GNI) in Namibia in 2007?
Offer a very short reply. -16.68. What is the difference between the Savings(% of GNI) of South Asia in 2004 and the Savings(% of GNI) of Ireland in 2007?
Offer a terse response. 0.98. What is the difference between the Savings(% of GNI) in South Asia in 2004 and the Savings(% of GNI) in Namibia in 2007?
Give a very brief answer. -2.23. What is the difference between the Savings(% of GNI) of Ireland in 2004 and the Savings(% of GNI) of Namibia in 2007?
Make the answer very short. 2.08. What is the difference between the Savings(% of GNI) of North America in 2005 and the Savings(% of GNI) of South Asia in 2006?
Offer a terse response. -15.53. What is the difference between the Savings(% of GNI) in North America in 2005 and the Savings(% of GNI) in Ireland in 2006?
Your answer should be very brief. -17.1. What is the difference between the Savings(% of GNI) in North America in 2005 and the Savings(% of GNI) in Namibia in 2006?
Your answer should be compact. -25.99. What is the difference between the Savings(% of GNI) of South Asia in 2005 and the Savings(% of GNI) of Ireland in 2006?
Make the answer very short. -1.89. What is the difference between the Savings(% of GNI) in South Asia in 2005 and the Savings(% of GNI) in Namibia in 2006?
Offer a terse response. -10.78. What is the difference between the Savings(% of GNI) of Ireland in 2005 and the Savings(% of GNI) of Namibia in 2006?
Your answer should be compact. -7.4. What is the difference between the Savings(% of GNI) in North America in 2005 and the Savings(% of GNI) in South Asia in 2007?
Offer a very short reply. -16.94. What is the difference between the Savings(% of GNI) of North America in 2005 and the Savings(% of GNI) of Ireland in 2007?
Ensure brevity in your answer.  -13.82. What is the difference between the Savings(% of GNI) of North America in 2005 and the Savings(% of GNI) of Namibia in 2007?
Offer a very short reply. -17.03. What is the difference between the Savings(% of GNI) of South Asia in 2005 and the Savings(% of GNI) of Ireland in 2007?
Offer a very short reply. 1.39. What is the difference between the Savings(% of GNI) of South Asia in 2005 and the Savings(% of GNI) of Namibia in 2007?
Keep it short and to the point. -1.82. What is the difference between the Savings(% of GNI) in Ireland in 2005 and the Savings(% of GNI) in Namibia in 2007?
Give a very brief answer. 1.56. What is the difference between the Savings(% of GNI) of North America in 2006 and the Savings(% of GNI) of South Asia in 2007?
Provide a succinct answer. -15.89. What is the difference between the Savings(% of GNI) of North America in 2006 and the Savings(% of GNI) of Ireland in 2007?
Ensure brevity in your answer.  -12.77. What is the difference between the Savings(% of GNI) in North America in 2006 and the Savings(% of GNI) in Namibia in 2007?
Provide a succinct answer. -15.98. What is the difference between the Savings(% of GNI) of South Asia in 2006 and the Savings(% of GNI) of Ireland in 2007?
Ensure brevity in your answer.  1.71. What is the difference between the Savings(% of GNI) in South Asia in 2006 and the Savings(% of GNI) in Namibia in 2007?
Your answer should be compact. -1.5. What is the difference between the Savings(% of GNI) of Ireland in 2006 and the Savings(% of GNI) of Namibia in 2007?
Provide a short and direct response. 0.07. What is the average Savings(% of GNI) of North America per year?
Ensure brevity in your answer.  7.05. What is the average Savings(% of GNI) of South Asia per year?
Ensure brevity in your answer.  18.86. What is the average Savings(% of GNI) of Ireland per year?
Provide a short and direct response. 22.93. What is the average Savings(% of GNI) of Namibia per year?
Provide a succinct answer. 22.92. In the year 2000, what is the difference between the Savings(% of GNI) of North America and Savings(% of GNI) of South Asia?
Your response must be concise. -5.27. In the year 2000, what is the difference between the Savings(% of GNI) of North America and Savings(% of GNI) of Ireland?
Offer a terse response. -12.55. In the year 2000, what is the difference between the Savings(% of GNI) of North America and Savings(% of GNI) of Namibia?
Offer a terse response. -12.53. In the year 2000, what is the difference between the Savings(% of GNI) of South Asia and Savings(% of GNI) of Ireland?
Provide a succinct answer. -7.28. In the year 2000, what is the difference between the Savings(% of GNI) of South Asia and Savings(% of GNI) of Namibia?
Keep it short and to the point. -7.25. In the year 2000, what is the difference between the Savings(% of GNI) of Ireland and Savings(% of GNI) of Namibia?
Provide a succinct answer. 0.02. In the year 2001, what is the difference between the Savings(% of GNI) in North America and Savings(% of GNI) in South Asia?
Provide a succinct answer. -7.56. In the year 2001, what is the difference between the Savings(% of GNI) of North America and Savings(% of GNI) of Ireland?
Provide a short and direct response. -13.16. In the year 2001, what is the difference between the Savings(% of GNI) in North America and Savings(% of GNI) in Namibia?
Offer a terse response. -12.94. In the year 2001, what is the difference between the Savings(% of GNI) of South Asia and Savings(% of GNI) of Ireland?
Provide a succinct answer. -5.6. In the year 2001, what is the difference between the Savings(% of GNI) of South Asia and Savings(% of GNI) of Namibia?
Your answer should be compact. -5.38. In the year 2001, what is the difference between the Savings(% of GNI) in Ireland and Savings(% of GNI) in Namibia?
Ensure brevity in your answer.  0.22. In the year 2002, what is the difference between the Savings(% of GNI) in North America and Savings(% of GNI) in South Asia?
Offer a very short reply. -8.8. In the year 2002, what is the difference between the Savings(% of GNI) in North America and Savings(% of GNI) in Ireland?
Offer a very short reply. -15.31. In the year 2002, what is the difference between the Savings(% of GNI) of North America and Savings(% of GNI) of Namibia?
Offer a terse response. -13.62. In the year 2002, what is the difference between the Savings(% of GNI) of South Asia and Savings(% of GNI) of Ireland?
Offer a terse response. -6.51. In the year 2002, what is the difference between the Savings(% of GNI) in South Asia and Savings(% of GNI) in Namibia?
Keep it short and to the point. -4.82. In the year 2002, what is the difference between the Savings(% of GNI) in Ireland and Savings(% of GNI) in Namibia?
Offer a terse response. 1.69. In the year 2003, what is the difference between the Savings(% of GNI) of North America and Savings(% of GNI) of South Asia?
Keep it short and to the point. -10.88. In the year 2003, what is the difference between the Savings(% of GNI) of North America and Savings(% of GNI) of Ireland?
Your answer should be very brief. -17.87. In the year 2003, what is the difference between the Savings(% of GNI) of North America and Savings(% of GNI) of Namibia?
Give a very brief answer. -11.9. In the year 2003, what is the difference between the Savings(% of GNI) in South Asia and Savings(% of GNI) in Ireland?
Provide a short and direct response. -6.98. In the year 2003, what is the difference between the Savings(% of GNI) in South Asia and Savings(% of GNI) in Namibia?
Your response must be concise. -1.01. In the year 2003, what is the difference between the Savings(% of GNI) in Ireland and Savings(% of GNI) in Namibia?
Give a very brief answer. 5.97. In the year 2004, what is the difference between the Savings(% of GNI) of North America and Savings(% of GNI) of South Asia?
Give a very brief answer. -14.45. In the year 2004, what is the difference between the Savings(% of GNI) of North America and Savings(% of GNI) of Ireland?
Keep it short and to the point. -18.76. In the year 2004, what is the difference between the Savings(% of GNI) of North America and Savings(% of GNI) of Namibia?
Make the answer very short. -16.59. In the year 2004, what is the difference between the Savings(% of GNI) in South Asia and Savings(% of GNI) in Ireland?
Your response must be concise. -4.31. In the year 2004, what is the difference between the Savings(% of GNI) in South Asia and Savings(% of GNI) in Namibia?
Your response must be concise. -2.14. In the year 2004, what is the difference between the Savings(% of GNI) of Ireland and Savings(% of GNI) of Namibia?
Make the answer very short. 2.17. In the year 2005, what is the difference between the Savings(% of GNI) in North America and Savings(% of GNI) in South Asia?
Your response must be concise. -15.21. In the year 2005, what is the difference between the Savings(% of GNI) of North America and Savings(% of GNI) of Ireland?
Your response must be concise. -18.59. In the year 2005, what is the difference between the Savings(% of GNI) of North America and Savings(% of GNI) of Namibia?
Offer a very short reply. -16.53. In the year 2005, what is the difference between the Savings(% of GNI) in South Asia and Savings(% of GNI) in Ireland?
Your response must be concise. -3.38. In the year 2005, what is the difference between the Savings(% of GNI) of South Asia and Savings(% of GNI) of Namibia?
Provide a succinct answer. -1.31. In the year 2005, what is the difference between the Savings(% of GNI) of Ireland and Savings(% of GNI) of Namibia?
Your answer should be compact. 2.06. In the year 2006, what is the difference between the Savings(% of GNI) of North America and Savings(% of GNI) of South Asia?
Provide a succinct answer. -14.48. In the year 2006, what is the difference between the Savings(% of GNI) in North America and Savings(% of GNI) in Ireland?
Your answer should be compact. -16.05. In the year 2006, what is the difference between the Savings(% of GNI) in North America and Savings(% of GNI) in Namibia?
Make the answer very short. -24.94. In the year 2006, what is the difference between the Savings(% of GNI) of South Asia and Savings(% of GNI) of Ireland?
Make the answer very short. -1.57. In the year 2006, what is the difference between the Savings(% of GNI) in South Asia and Savings(% of GNI) in Namibia?
Offer a very short reply. -10.46. In the year 2006, what is the difference between the Savings(% of GNI) in Ireland and Savings(% of GNI) in Namibia?
Your answer should be very brief. -8.89. In the year 2007, what is the difference between the Savings(% of GNI) of North America and Savings(% of GNI) of South Asia?
Your answer should be compact. -17.83. In the year 2007, what is the difference between the Savings(% of GNI) of North America and Savings(% of GNI) of Ireland?
Make the answer very short. -14.71. In the year 2007, what is the difference between the Savings(% of GNI) of North America and Savings(% of GNI) of Namibia?
Give a very brief answer. -17.93. In the year 2007, what is the difference between the Savings(% of GNI) in South Asia and Savings(% of GNI) in Ireland?
Offer a terse response. 3.11. In the year 2007, what is the difference between the Savings(% of GNI) in South Asia and Savings(% of GNI) in Namibia?
Provide a short and direct response. -0.1. In the year 2007, what is the difference between the Savings(% of GNI) of Ireland and Savings(% of GNI) of Namibia?
Offer a terse response. -3.21. What is the ratio of the Savings(% of GNI) in North America in 2000 to that in 2001?
Your response must be concise. 1.14. What is the ratio of the Savings(% of GNI) of South Asia in 2000 to that in 2001?
Provide a succinct answer. 0.93. What is the ratio of the Savings(% of GNI) in Ireland in 2000 to that in 2001?
Offer a terse response. 1.03. What is the ratio of the Savings(% of GNI) in Namibia in 2000 to that in 2001?
Offer a very short reply. 1.04. What is the ratio of the Savings(% of GNI) in North America in 2000 to that in 2002?
Provide a succinct answer. 1.32. What is the ratio of the Savings(% of GNI) in South Asia in 2000 to that in 2002?
Offer a very short reply. 0.92. What is the ratio of the Savings(% of GNI) in Ireland in 2000 to that in 2002?
Make the answer very short. 0.98. What is the ratio of the Savings(% of GNI) in Namibia in 2000 to that in 2002?
Your answer should be compact. 1.06. What is the ratio of the Savings(% of GNI) of North America in 2000 to that in 2003?
Your answer should be very brief. 1.47. What is the ratio of the Savings(% of GNI) of South Asia in 2000 to that in 2003?
Make the answer very short. 0.85. What is the ratio of the Savings(% of GNI) of Ireland in 2000 to that in 2003?
Offer a very short reply. 0.9. What is the ratio of the Savings(% of GNI) of Namibia in 2000 to that in 2003?
Your answer should be very brief. 1.2. What is the ratio of the Savings(% of GNI) of North America in 2000 to that in 2004?
Offer a terse response. 1.45. What is the ratio of the Savings(% of GNI) in South Asia in 2000 to that in 2004?
Offer a terse response. 0.7. What is the ratio of the Savings(% of GNI) of Ireland in 2000 to that in 2004?
Your answer should be compact. 0.87. What is the ratio of the Savings(% of GNI) in Namibia in 2000 to that in 2004?
Give a very brief answer. 0.95. What is the ratio of the Savings(% of GNI) of North America in 2000 to that in 2005?
Offer a very short reply. 1.54. What is the ratio of the Savings(% of GNI) in South Asia in 2000 to that in 2005?
Provide a succinct answer. 0.69. What is the ratio of the Savings(% of GNI) in Ireland in 2000 to that in 2005?
Provide a short and direct response. 0.89. What is the ratio of the Savings(% of GNI) in Namibia in 2000 to that in 2005?
Provide a succinct answer. 0.97. What is the ratio of the Savings(% of GNI) of North America in 2000 to that in 2006?
Ensure brevity in your answer.  1.31. What is the ratio of the Savings(% of GNI) in South Asia in 2000 to that in 2006?
Give a very brief answer. 0.68. What is the ratio of the Savings(% of GNI) in Ireland in 2000 to that in 2006?
Ensure brevity in your answer.  0.95. What is the ratio of the Savings(% of GNI) of Namibia in 2000 to that in 2006?
Your answer should be compact. 0.68. What is the ratio of the Savings(% of GNI) in North America in 2000 to that in 2007?
Offer a very short reply. 1.8. What is the ratio of the Savings(% of GNI) of South Asia in 2000 to that in 2007?
Keep it short and to the point. 0.64. What is the ratio of the Savings(% of GNI) of Ireland in 2000 to that in 2007?
Your answer should be compact. 1.1. What is the ratio of the Savings(% of GNI) in Namibia in 2000 to that in 2007?
Offer a terse response. 0.95. What is the ratio of the Savings(% of GNI) of North America in 2001 to that in 2002?
Ensure brevity in your answer.  1.16. What is the ratio of the Savings(% of GNI) in South Asia in 2001 to that in 2002?
Provide a short and direct response. 0.99. What is the ratio of the Savings(% of GNI) of Ireland in 2001 to that in 2002?
Give a very brief answer. 0.96. What is the ratio of the Savings(% of GNI) in Namibia in 2001 to that in 2002?
Offer a terse response. 1.02. What is the ratio of the Savings(% of GNI) of North America in 2001 to that in 2003?
Ensure brevity in your answer.  1.28. What is the ratio of the Savings(% of GNI) in South Asia in 2001 to that in 2003?
Provide a succinct answer. 0.91. What is the ratio of the Savings(% of GNI) in Ireland in 2001 to that in 2003?
Your answer should be very brief. 0.88. What is the ratio of the Savings(% of GNI) in Namibia in 2001 to that in 2003?
Your response must be concise. 1.16. What is the ratio of the Savings(% of GNI) in North America in 2001 to that in 2004?
Provide a short and direct response. 1.27. What is the ratio of the Savings(% of GNI) of South Asia in 2001 to that in 2004?
Your response must be concise. 0.76. What is the ratio of the Savings(% of GNI) in Ireland in 2001 to that in 2004?
Provide a short and direct response. 0.85. What is the ratio of the Savings(% of GNI) of Namibia in 2001 to that in 2004?
Your answer should be very brief. 0.92. What is the ratio of the Savings(% of GNI) of North America in 2001 to that in 2005?
Your response must be concise. 1.35. What is the ratio of the Savings(% of GNI) of South Asia in 2001 to that in 2005?
Give a very brief answer. 0.74. What is the ratio of the Savings(% of GNI) in Ireland in 2001 to that in 2005?
Ensure brevity in your answer.  0.87. What is the ratio of the Savings(% of GNI) in Namibia in 2001 to that in 2005?
Provide a succinct answer. 0.94. What is the ratio of the Savings(% of GNI) in North America in 2001 to that in 2006?
Provide a short and direct response. 1.15. What is the ratio of the Savings(% of GNI) of South Asia in 2001 to that in 2006?
Your answer should be compact. 0.73. What is the ratio of the Savings(% of GNI) in Ireland in 2001 to that in 2006?
Make the answer very short. 0.92. What is the ratio of the Savings(% of GNI) of Namibia in 2001 to that in 2006?
Give a very brief answer. 0.66. What is the ratio of the Savings(% of GNI) in North America in 2001 to that in 2007?
Give a very brief answer. 1.57. What is the ratio of the Savings(% of GNI) in South Asia in 2001 to that in 2007?
Provide a short and direct response. 0.69. What is the ratio of the Savings(% of GNI) of Ireland in 2001 to that in 2007?
Offer a terse response. 1.07. What is the ratio of the Savings(% of GNI) of Namibia in 2001 to that in 2007?
Ensure brevity in your answer.  0.92. What is the ratio of the Savings(% of GNI) of North America in 2002 to that in 2003?
Give a very brief answer. 1.11. What is the ratio of the Savings(% of GNI) in South Asia in 2002 to that in 2003?
Offer a very short reply. 0.92. What is the ratio of the Savings(% of GNI) in Ireland in 2002 to that in 2003?
Provide a succinct answer. 0.92. What is the ratio of the Savings(% of GNI) of Namibia in 2002 to that in 2003?
Keep it short and to the point. 1.13. What is the ratio of the Savings(% of GNI) in North America in 2002 to that in 2004?
Give a very brief answer. 1.1. What is the ratio of the Savings(% of GNI) in South Asia in 2002 to that in 2004?
Offer a terse response. 0.76. What is the ratio of the Savings(% of GNI) in Ireland in 2002 to that in 2004?
Keep it short and to the point. 0.89. What is the ratio of the Savings(% of GNI) of Namibia in 2002 to that in 2004?
Give a very brief answer. 0.9. What is the ratio of the Savings(% of GNI) of North America in 2002 to that in 2005?
Your answer should be very brief. 1.16. What is the ratio of the Savings(% of GNI) in South Asia in 2002 to that in 2005?
Offer a terse response. 0.75. What is the ratio of the Savings(% of GNI) of Ireland in 2002 to that in 2005?
Give a very brief answer. 0.91. What is the ratio of the Savings(% of GNI) of Namibia in 2002 to that in 2005?
Provide a succinct answer. 0.92. What is the ratio of the Savings(% of GNI) of North America in 2002 to that in 2006?
Provide a short and direct response. 0.99. What is the ratio of the Savings(% of GNI) of South Asia in 2002 to that in 2006?
Make the answer very short. 0.73. What is the ratio of the Savings(% of GNI) in Ireland in 2002 to that in 2006?
Offer a very short reply. 0.97. What is the ratio of the Savings(% of GNI) in Namibia in 2002 to that in 2006?
Your answer should be compact. 0.65. What is the ratio of the Savings(% of GNI) in North America in 2002 to that in 2007?
Offer a terse response. 1.36. What is the ratio of the Savings(% of GNI) of South Asia in 2002 to that in 2007?
Make the answer very short. 0.69. What is the ratio of the Savings(% of GNI) of Ireland in 2002 to that in 2007?
Provide a succinct answer. 1.12. What is the ratio of the Savings(% of GNI) in Namibia in 2002 to that in 2007?
Give a very brief answer. 0.9. What is the ratio of the Savings(% of GNI) in South Asia in 2003 to that in 2004?
Make the answer very short. 0.83. What is the ratio of the Savings(% of GNI) in Ireland in 2003 to that in 2004?
Offer a terse response. 0.96. What is the ratio of the Savings(% of GNI) in Namibia in 2003 to that in 2004?
Make the answer very short. 0.79. What is the ratio of the Savings(% of GNI) in North America in 2003 to that in 2005?
Your answer should be compact. 1.05. What is the ratio of the Savings(% of GNI) in South Asia in 2003 to that in 2005?
Give a very brief answer. 0.81. What is the ratio of the Savings(% of GNI) of Ireland in 2003 to that in 2005?
Make the answer very short. 0.98. What is the ratio of the Savings(% of GNI) in Namibia in 2003 to that in 2005?
Provide a short and direct response. 0.81. What is the ratio of the Savings(% of GNI) in North America in 2003 to that in 2006?
Offer a very short reply. 0.89. What is the ratio of the Savings(% of GNI) of South Asia in 2003 to that in 2006?
Offer a terse response. 0.8. What is the ratio of the Savings(% of GNI) in Ireland in 2003 to that in 2006?
Provide a succinct answer. 1.05. What is the ratio of the Savings(% of GNI) in Namibia in 2003 to that in 2006?
Offer a very short reply. 0.57. What is the ratio of the Savings(% of GNI) in North America in 2003 to that in 2007?
Keep it short and to the point. 1.23. What is the ratio of the Savings(% of GNI) of South Asia in 2003 to that in 2007?
Provide a succinct answer. 0.75. What is the ratio of the Savings(% of GNI) of Ireland in 2003 to that in 2007?
Provide a succinct answer. 1.22. What is the ratio of the Savings(% of GNI) in Namibia in 2003 to that in 2007?
Give a very brief answer. 0.79. What is the ratio of the Savings(% of GNI) in North America in 2004 to that in 2005?
Keep it short and to the point. 1.06. What is the ratio of the Savings(% of GNI) of South Asia in 2004 to that in 2005?
Provide a short and direct response. 0.98. What is the ratio of the Savings(% of GNI) in Ireland in 2004 to that in 2005?
Give a very brief answer. 1.02. What is the ratio of the Savings(% of GNI) in Namibia in 2004 to that in 2005?
Offer a terse response. 1.02. What is the ratio of the Savings(% of GNI) of North America in 2004 to that in 2006?
Your answer should be compact. 0.9. What is the ratio of the Savings(% of GNI) in South Asia in 2004 to that in 2006?
Offer a very short reply. 0.97. What is the ratio of the Savings(% of GNI) in Ireland in 2004 to that in 2006?
Your answer should be very brief. 1.09. What is the ratio of the Savings(% of GNI) of Namibia in 2004 to that in 2006?
Make the answer very short. 0.72. What is the ratio of the Savings(% of GNI) of North America in 2004 to that in 2007?
Your response must be concise. 1.24. What is the ratio of the Savings(% of GNI) in South Asia in 2004 to that in 2007?
Keep it short and to the point. 0.91. What is the ratio of the Savings(% of GNI) of Ireland in 2004 to that in 2007?
Your response must be concise. 1.26. What is the ratio of the Savings(% of GNI) in North America in 2005 to that in 2006?
Your answer should be compact. 0.85. What is the ratio of the Savings(% of GNI) in South Asia in 2005 to that in 2006?
Make the answer very short. 0.99. What is the ratio of the Savings(% of GNI) in Ireland in 2005 to that in 2006?
Your answer should be very brief. 1.06. What is the ratio of the Savings(% of GNI) of Namibia in 2005 to that in 2006?
Your response must be concise. 0.71. What is the ratio of the Savings(% of GNI) in North America in 2005 to that in 2007?
Provide a succinct answer. 1.17. What is the ratio of the Savings(% of GNI) in South Asia in 2005 to that in 2007?
Ensure brevity in your answer.  0.93. What is the ratio of the Savings(% of GNI) of Ireland in 2005 to that in 2007?
Keep it short and to the point. 1.24. What is the ratio of the Savings(% of GNI) in Namibia in 2005 to that in 2007?
Your response must be concise. 0.98. What is the ratio of the Savings(% of GNI) of North America in 2006 to that in 2007?
Your response must be concise. 1.37. What is the ratio of the Savings(% of GNI) in South Asia in 2006 to that in 2007?
Keep it short and to the point. 0.94. What is the ratio of the Savings(% of GNI) in Ireland in 2006 to that in 2007?
Your answer should be very brief. 1.16. What is the ratio of the Savings(% of GNI) of Namibia in 2006 to that in 2007?
Offer a terse response. 1.39. What is the difference between the highest and the second highest Savings(% of GNI) in North America?
Offer a very short reply. 1.16. What is the difference between the highest and the second highest Savings(% of GNI) of South Asia?
Your answer should be compact. 1.41. What is the difference between the highest and the second highest Savings(% of GNI) of Ireland?
Offer a very short reply. 0.52. What is the difference between the highest and the second highest Savings(% of GNI) in Namibia?
Your response must be concise. 8.96. What is the difference between the highest and the lowest Savings(% of GNI) in North America?
Give a very brief answer. 4.18. What is the difference between the highest and the lowest Savings(% of GNI) in South Asia?
Provide a succinct answer. 8.37. What is the difference between the highest and the lowest Savings(% of GNI) of Ireland?
Your answer should be compact. 5.29. What is the difference between the highest and the lowest Savings(% of GNI) of Namibia?
Your response must be concise. 13.8. 